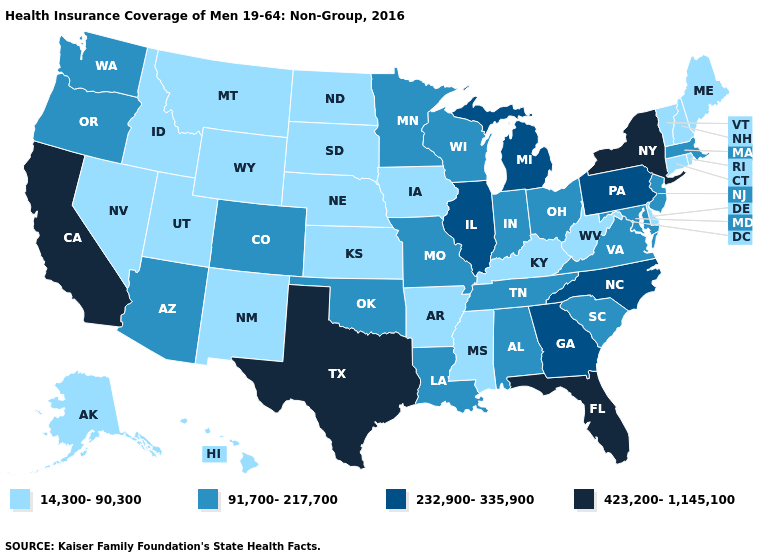Which states have the lowest value in the USA?
Quick response, please. Alaska, Arkansas, Connecticut, Delaware, Hawaii, Idaho, Iowa, Kansas, Kentucky, Maine, Mississippi, Montana, Nebraska, Nevada, New Hampshire, New Mexico, North Dakota, Rhode Island, South Dakota, Utah, Vermont, West Virginia, Wyoming. What is the value of New York?
Quick response, please. 423,200-1,145,100. Is the legend a continuous bar?
Short answer required. No. What is the highest value in the South ?
Give a very brief answer. 423,200-1,145,100. Among the states that border Oklahoma , does New Mexico have the lowest value?
Concise answer only. Yes. Does Florida have the highest value in the South?
Keep it brief. Yes. Which states have the lowest value in the USA?
Be succinct. Alaska, Arkansas, Connecticut, Delaware, Hawaii, Idaho, Iowa, Kansas, Kentucky, Maine, Mississippi, Montana, Nebraska, Nevada, New Hampshire, New Mexico, North Dakota, Rhode Island, South Dakota, Utah, Vermont, West Virginia, Wyoming. What is the value of Georgia?
Give a very brief answer. 232,900-335,900. Does Florida have the highest value in the South?
Write a very short answer. Yes. Name the states that have a value in the range 14,300-90,300?
Give a very brief answer. Alaska, Arkansas, Connecticut, Delaware, Hawaii, Idaho, Iowa, Kansas, Kentucky, Maine, Mississippi, Montana, Nebraska, Nevada, New Hampshire, New Mexico, North Dakota, Rhode Island, South Dakota, Utah, Vermont, West Virginia, Wyoming. Name the states that have a value in the range 423,200-1,145,100?
Answer briefly. California, Florida, New York, Texas. What is the lowest value in states that border Oklahoma?
Quick response, please. 14,300-90,300. Does West Virginia have a lower value than Missouri?
Quick response, please. Yes. What is the value of New Mexico?
Short answer required. 14,300-90,300. 